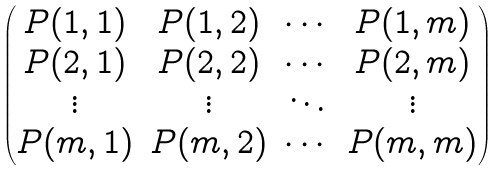<formula> <loc_0><loc_0><loc_500><loc_500>\begin{pmatrix} P ( 1 , 1 ) & P ( 1 , 2 ) & \cdots & P ( 1 , m ) \\ P ( 2 , 1 ) & P ( 2 , 2 ) & \cdots & P ( 2 , m ) \\ \vdots & \vdots & \ddots & \vdots \\ P ( m , 1 ) & P ( m , 2 ) & \cdots & P ( m , m ) \end{pmatrix}</formula> 